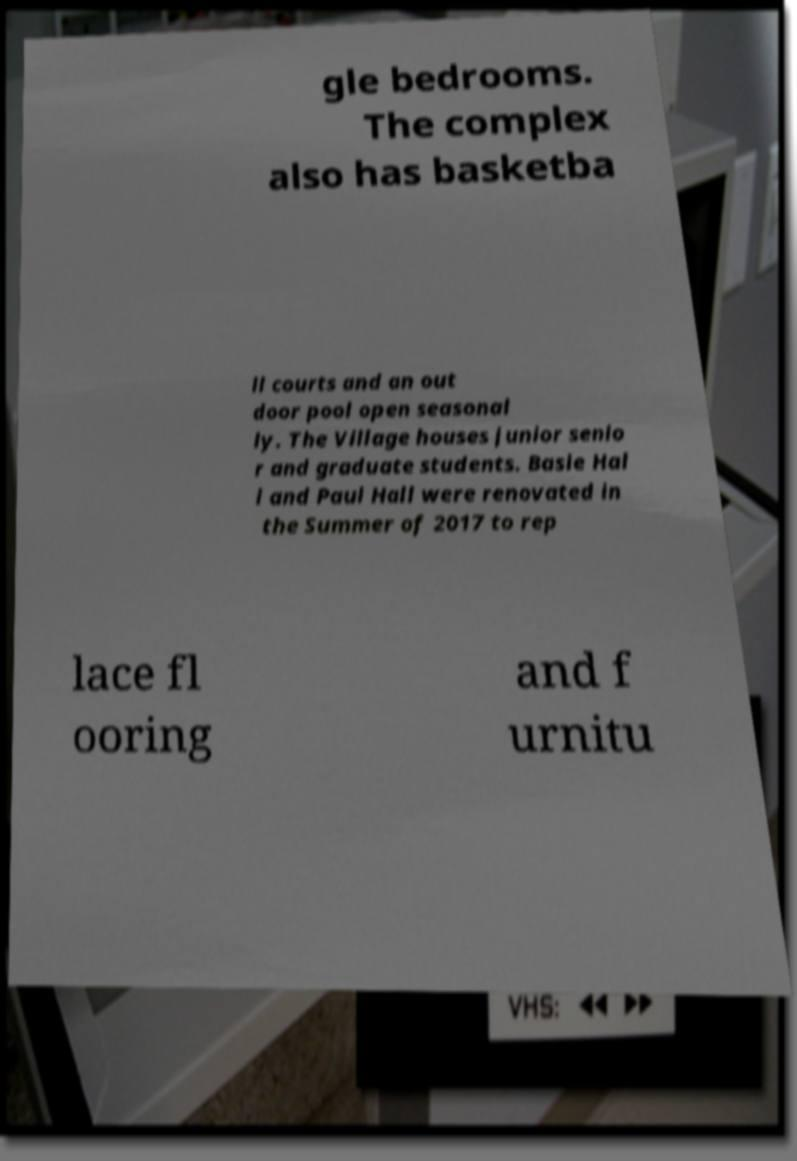Please identify and transcribe the text found in this image. gle bedrooms. The complex also has basketba ll courts and an out door pool open seasonal ly. The Village houses junior senio r and graduate students. Basie Hal l and Paul Hall were renovated in the Summer of 2017 to rep lace fl ooring and f urnitu 